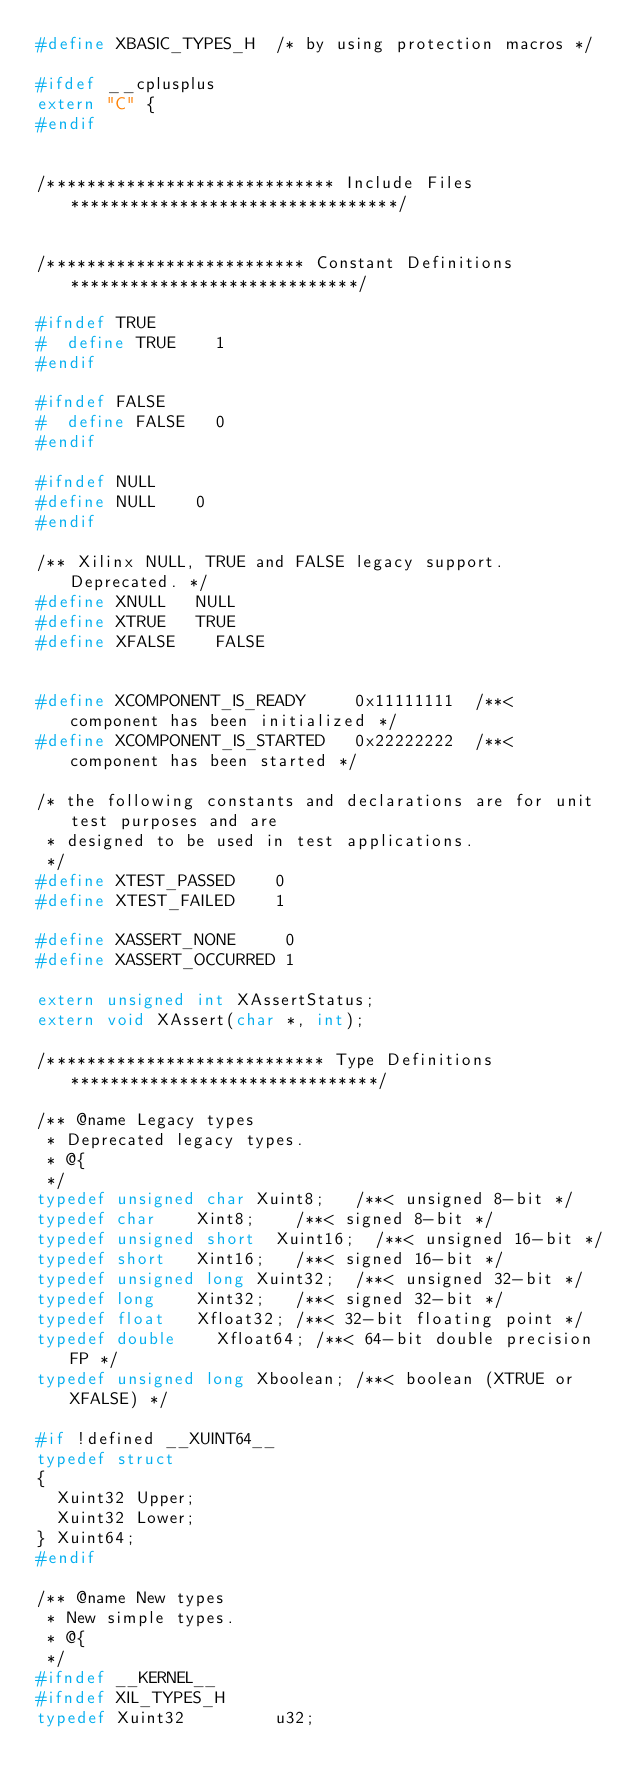Convert code to text. <code><loc_0><loc_0><loc_500><loc_500><_C_>#define XBASIC_TYPES_H	/* by using protection macros */

#ifdef __cplusplus
extern "C" {
#endif


/***************************** Include Files *********************************/


/************************** Constant Definitions *****************************/

#ifndef TRUE
#  define TRUE		1
#endif

#ifndef FALSE
#  define FALSE		0
#endif

#ifndef NULL
#define NULL		0
#endif

/** Xilinx NULL, TRUE and FALSE legacy support. Deprecated. */
#define XNULL		NULL
#define XTRUE		TRUE
#define XFALSE		FALSE


#define XCOMPONENT_IS_READY     0x11111111  /**< component has been initialized */
#define XCOMPONENT_IS_STARTED   0x22222222  /**< component has been started */

/* the following constants and declarations are for unit test purposes and are
 * designed to be used in test applications.
 */
#define XTEST_PASSED    0
#define XTEST_FAILED    1

#define XASSERT_NONE     0
#define XASSERT_OCCURRED 1

extern unsigned int XAssertStatus;
extern void XAssert(char *, int);

/**************************** Type Definitions *******************************/

/** @name Legacy types
 * Deprecated legacy types.
 * @{
 */
typedef unsigned char	Xuint8;		/**< unsigned 8-bit */
typedef char		Xint8;		/**< signed 8-bit */
typedef unsigned short	Xuint16;	/**< unsigned 16-bit */
typedef short		Xint16;		/**< signed 16-bit */
typedef unsigned long	Xuint32;	/**< unsigned 32-bit */
typedef long		Xint32;		/**< signed 32-bit */
typedef float		Xfloat32;	/**< 32-bit floating point */
typedef double		Xfloat64;	/**< 64-bit double precision FP */
typedef unsigned long	Xboolean;	/**< boolean (XTRUE or XFALSE) */

#if !defined __XUINT64__
typedef struct
{
	Xuint32 Upper;
	Xuint32 Lower;
} Xuint64;
#endif

/** @name New types
 * New simple types.
 * @{
 */
#ifndef __KERNEL__
#ifndef XIL_TYPES_H
typedef Xuint32         u32;</code> 